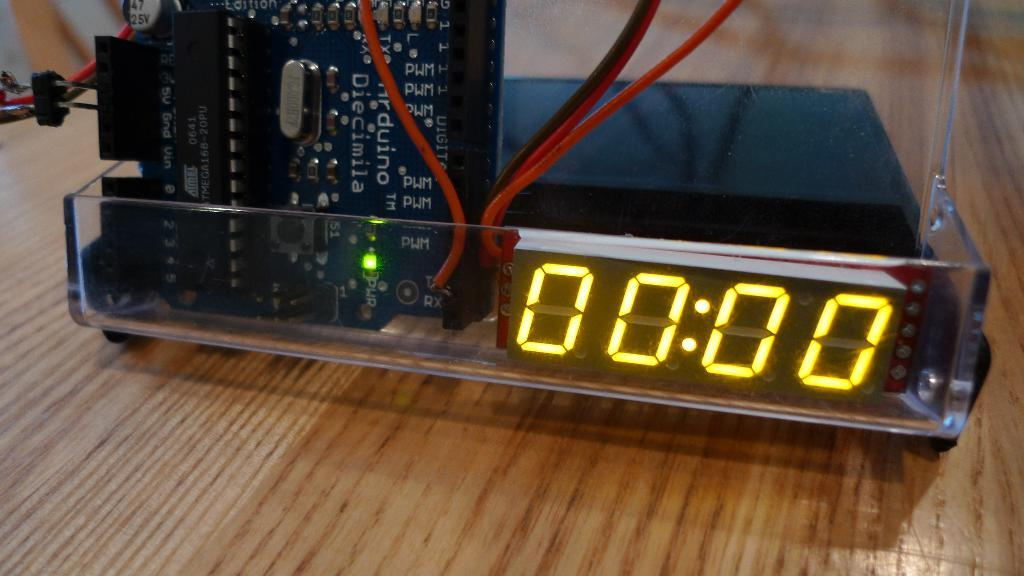<image>
Share a concise interpretation of the image provided. In a plastic case, an Arduino micro controller drives a display. 